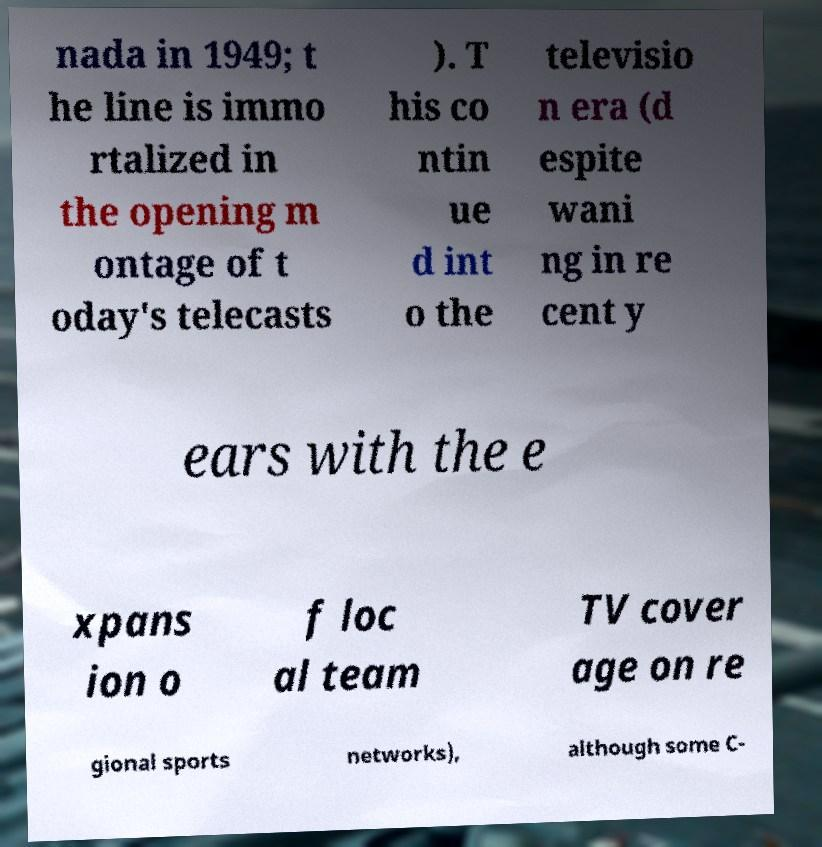Can you read and provide the text displayed in the image?This photo seems to have some interesting text. Can you extract and type it out for me? nada in 1949; t he line is immo rtalized in the opening m ontage of t oday's telecasts ). T his co ntin ue d int o the televisio n era (d espite wani ng in re cent y ears with the e xpans ion o f loc al team TV cover age on re gional sports networks), although some C- 